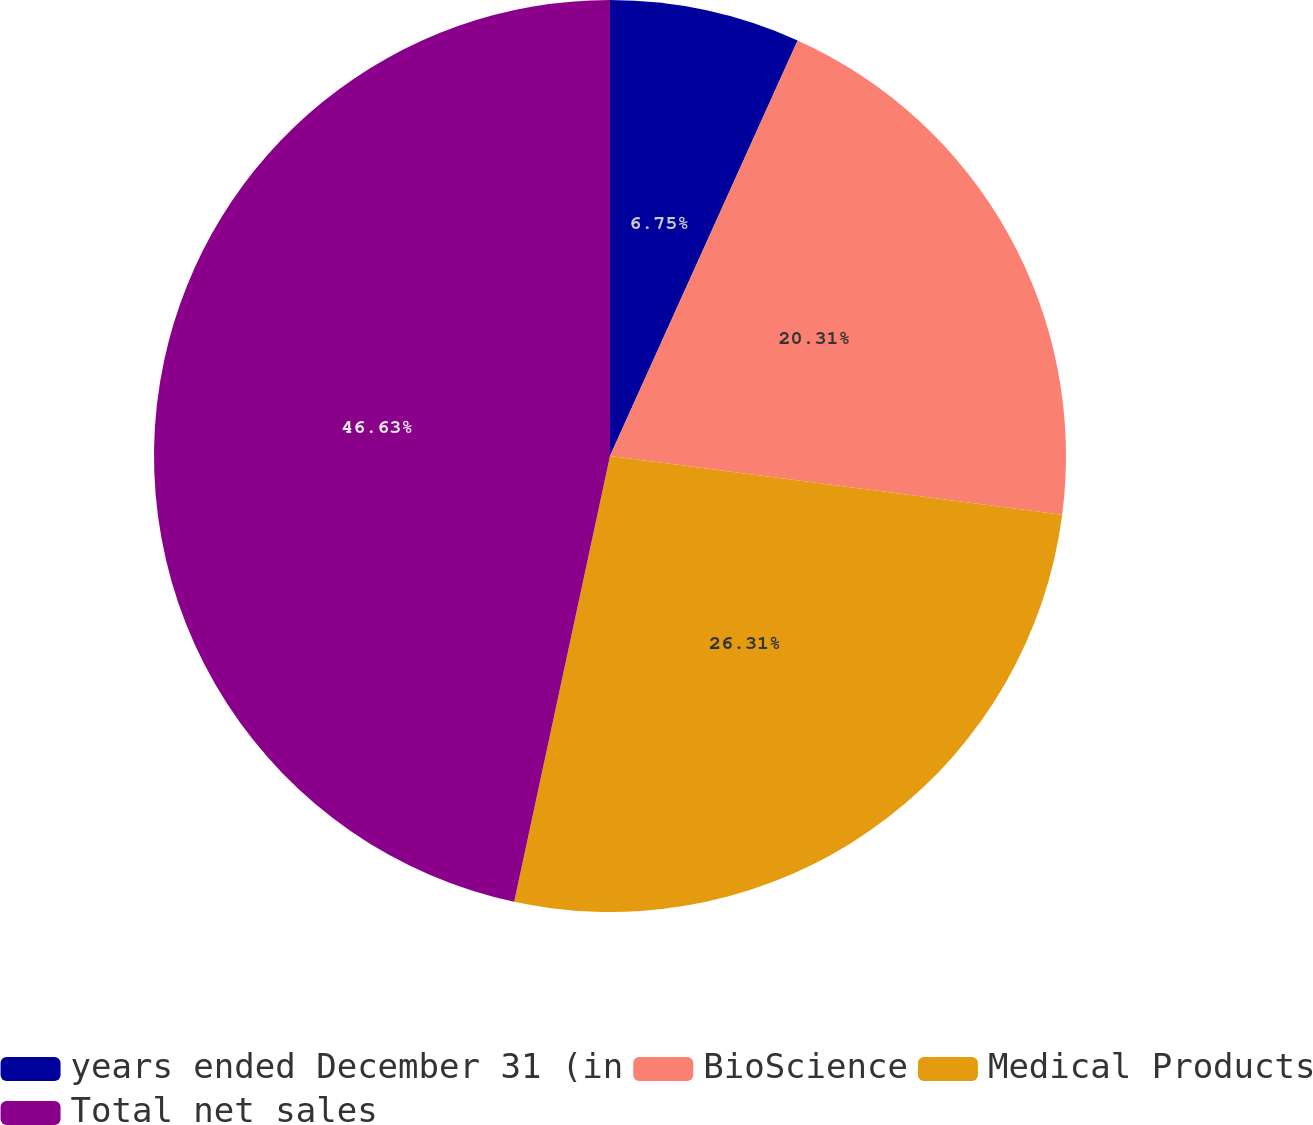<chart> <loc_0><loc_0><loc_500><loc_500><pie_chart><fcel>years ended December 31 (in<fcel>BioScience<fcel>Medical Products<fcel>Total net sales<nl><fcel>6.75%<fcel>20.31%<fcel>26.31%<fcel>46.63%<nl></chart> 